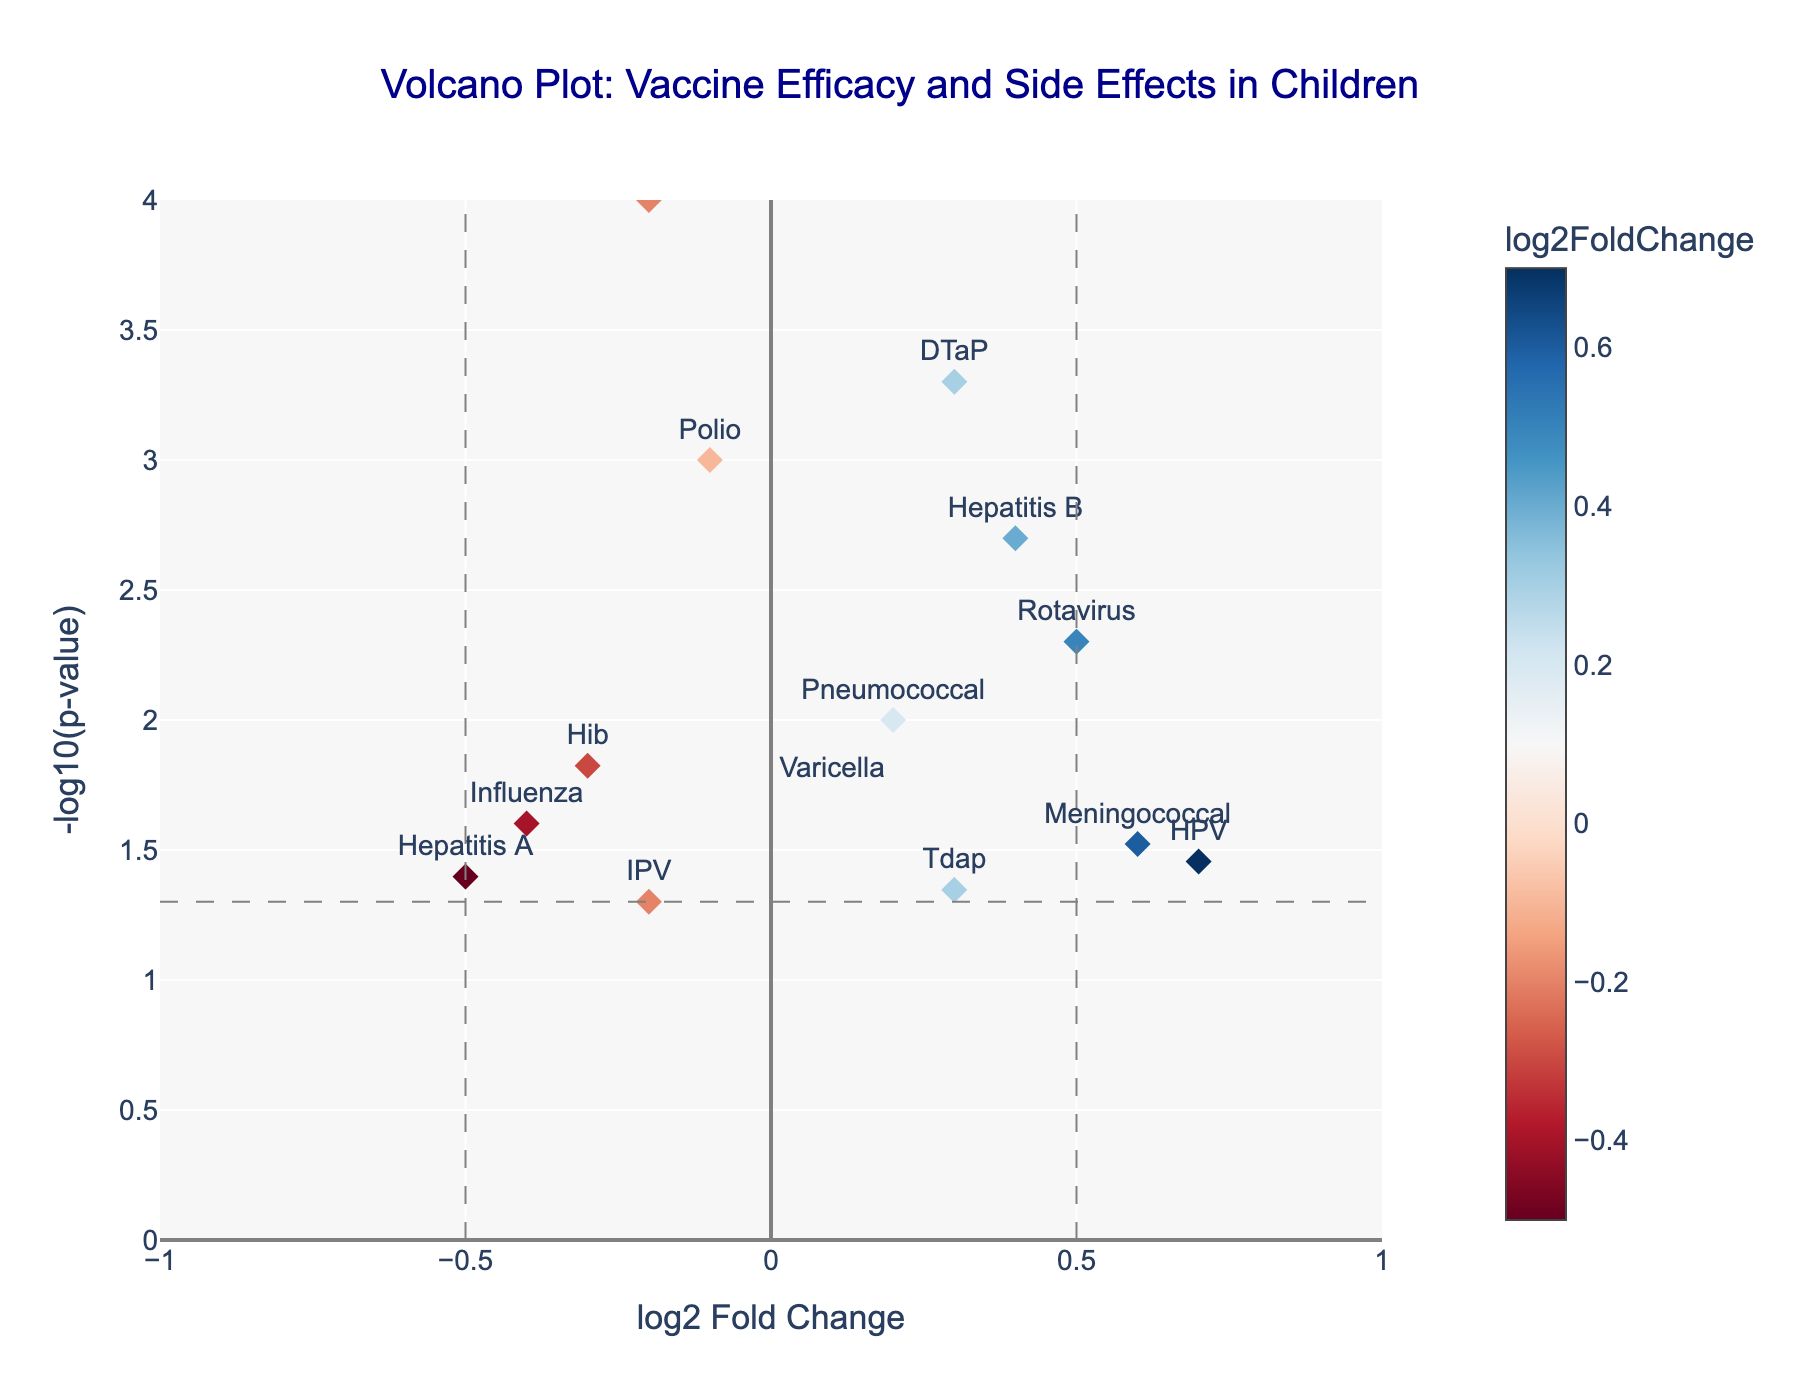Which vaccine is associated with the highest positive log2 fold change? By observing the x-axis (log2 Fold Change), the vaccine with the highest log2 fold change is on the far right. The highest value is 0.7, labeled as HPV.
Answer: HPV What is the significance (p-value) threshold marked on the plot? The horizontal dashed line represents the p-value threshold. This threshold is typically set at 0.05, and therefore -log10(0.05) is approximately 1.3 on the y-axis.
Answer: 0.05 How many vaccines show a significant change in efficacy (p-value < 0.05)? To determine this, identify all points above the horizontal dashed line (-log10(p-value) of 1.3). There are ten such points above this line.
Answer: 10 Which vaccine shows the largest decrease in efficacy? The vaccine with the lowest log2 fold change (most negative value) is on the far left of the plot. The lowest value is -0.5, labeled as Hepatitis A.
Answer: Hepatitis A Are there any vaccines with a log2 fold change close to zero but still statistically significant? Look for data points with a log2 fold change close to zero on the x-axis but above the 1.3 threshold on the y-axis. The MMR, Polio, and Hib vaccines fit this criterion.
Answer: MMR, Polio, Hib Which vaccine is just above the significance threshold with the highest positive log2 fold change? Find the point that is just above the horizontal dashed line at -log10(p-value) of 1.3 with the highest positive log2 fold change value. The HPV vaccine at log2 fold change of 0.7 meets this criterion.
Answer: HPV What is the log2 fold change and p-value for the DTaP vaccine? Locate the DTaP vaccine label on the plot. The hovertext shows log2 fold change of 0.3 and p-value of 0.0005.
Answer: log2 fold change: 0.3, p-value: 0.0005 Which three vaccines exhibit a negative log2 fold change but are still statistically significant? Identify vaccines with negative values on the x-axis and above -log10(p-value) of 1.3 on the y-axis. The vaccines are MMR, Polio, and Hib.
Answer: MMR, Polio, Hib How does the efficacy of the Influenza vaccine compare to the Varicella vaccine? Compare the log2 fold change values and p-values. The Influenza vaccine has a log2 fold change of -0.4 and Varicella has 0.1, indicating Influenza has a lower efficacy. Both are below the significance threshold.
Answer: Influenza is less effective than Varicella, both not significant Which vaccine with a positive log2 fold change has the lowest significance (highest p-value)? Among the data points with positive log2 fold change (right side of the plot), the one closest to the baseline (bottom of the plot) has the highest p-value. The Tdap vaccine near log2FC of 0.3 is the least significant.
Answer: Tdap 